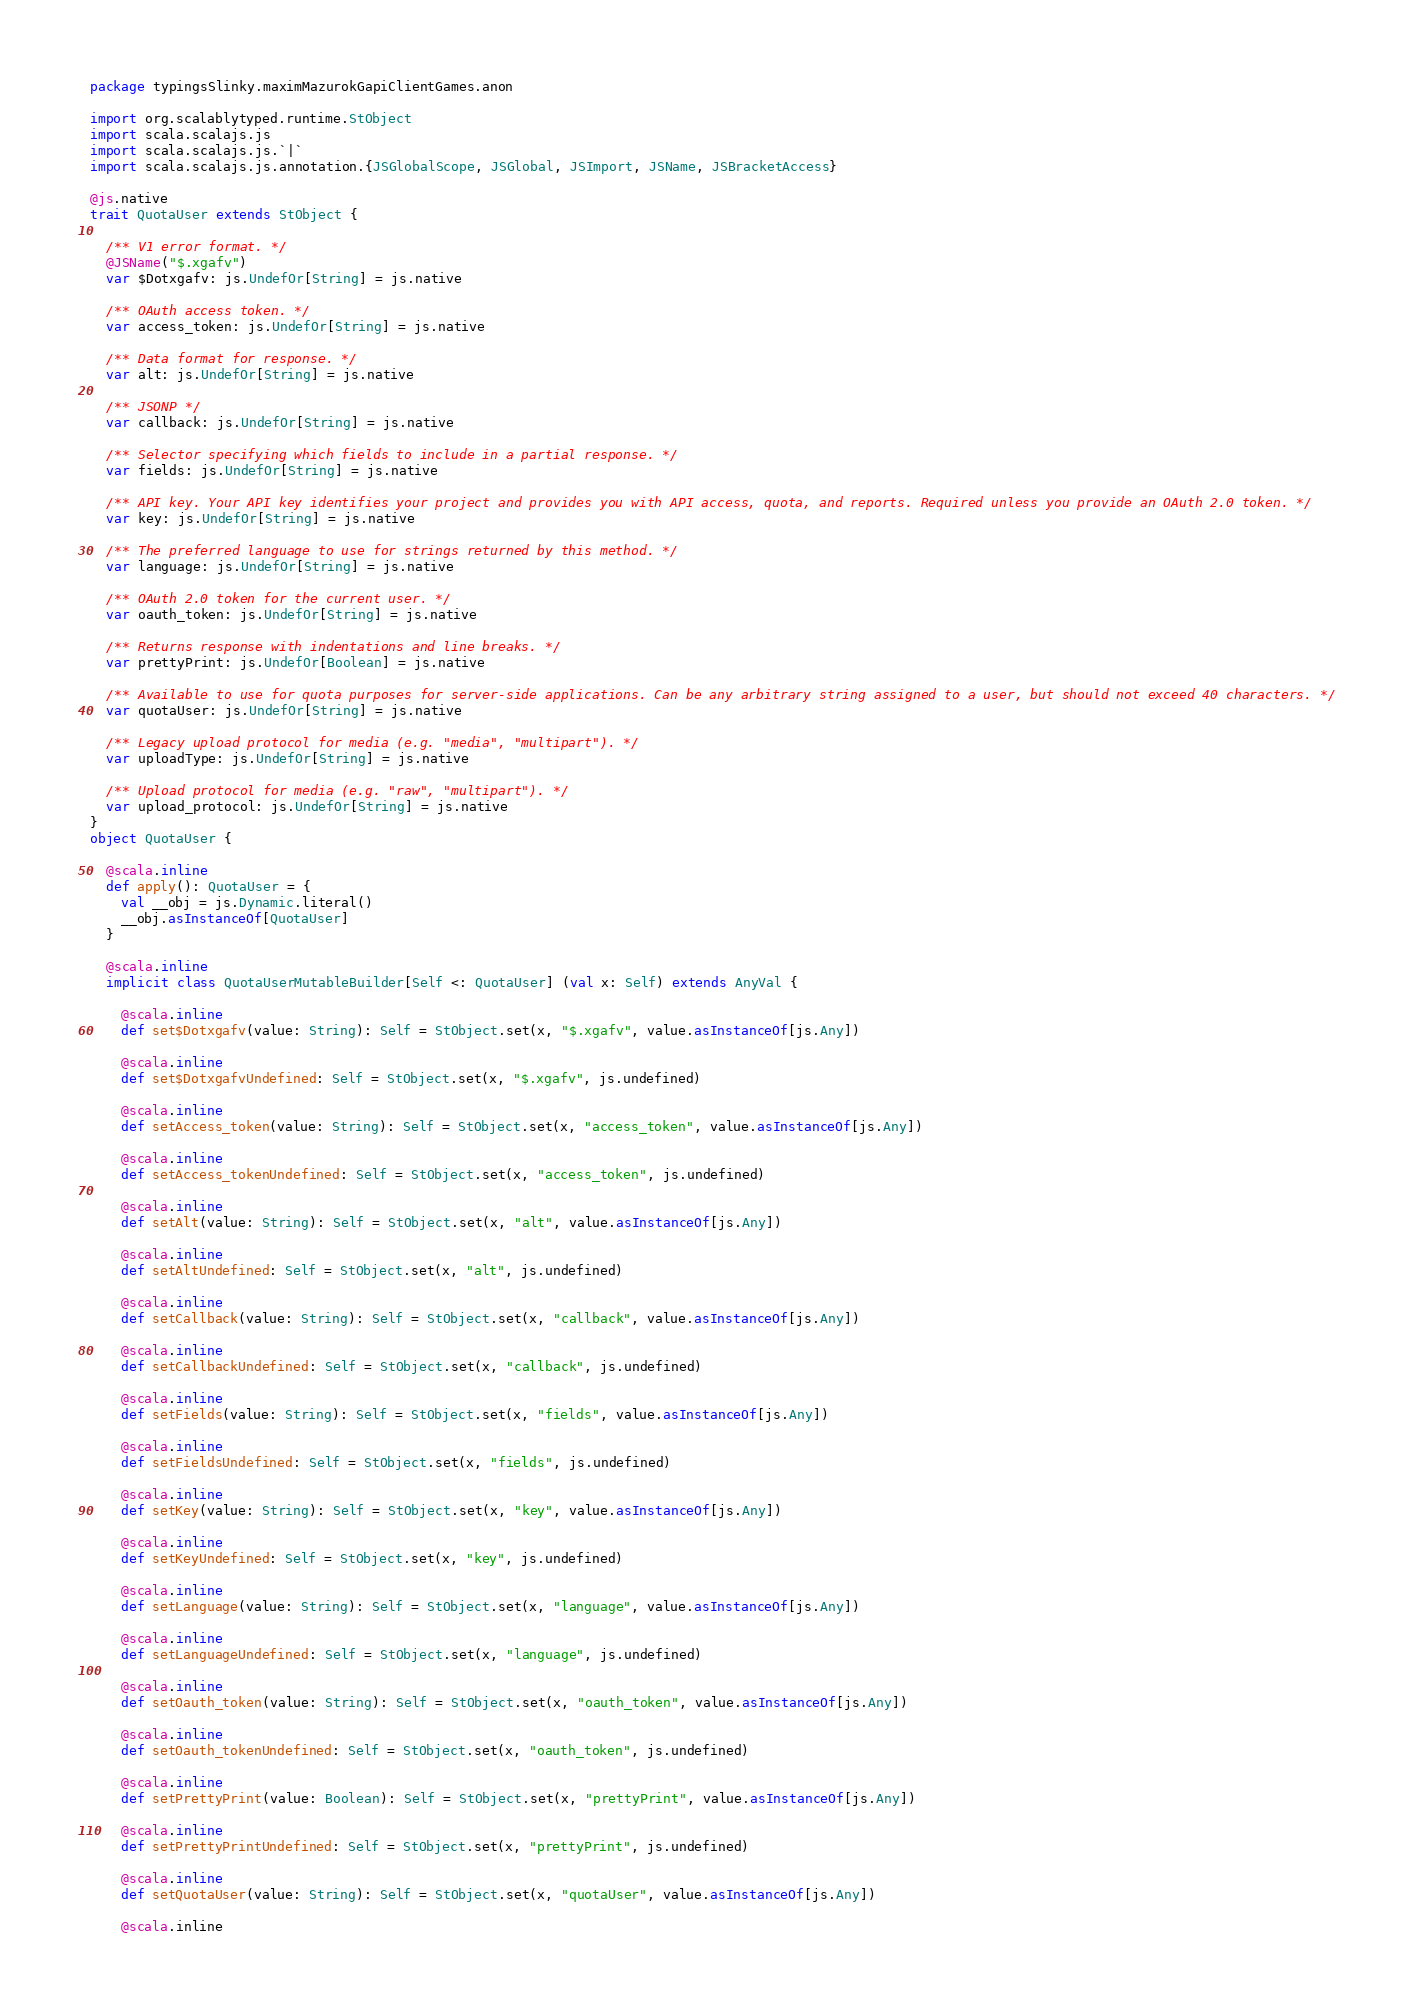Convert code to text. <code><loc_0><loc_0><loc_500><loc_500><_Scala_>package typingsSlinky.maximMazurokGapiClientGames.anon

import org.scalablytyped.runtime.StObject
import scala.scalajs.js
import scala.scalajs.js.`|`
import scala.scalajs.js.annotation.{JSGlobalScope, JSGlobal, JSImport, JSName, JSBracketAccess}

@js.native
trait QuotaUser extends StObject {
  
  /** V1 error format. */
  @JSName("$.xgafv")
  var $Dotxgafv: js.UndefOr[String] = js.native
  
  /** OAuth access token. */
  var access_token: js.UndefOr[String] = js.native
  
  /** Data format for response. */
  var alt: js.UndefOr[String] = js.native
  
  /** JSONP */
  var callback: js.UndefOr[String] = js.native
  
  /** Selector specifying which fields to include in a partial response. */
  var fields: js.UndefOr[String] = js.native
  
  /** API key. Your API key identifies your project and provides you with API access, quota, and reports. Required unless you provide an OAuth 2.0 token. */
  var key: js.UndefOr[String] = js.native
  
  /** The preferred language to use for strings returned by this method. */
  var language: js.UndefOr[String] = js.native
  
  /** OAuth 2.0 token for the current user. */
  var oauth_token: js.UndefOr[String] = js.native
  
  /** Returns response with indentations and line breaks. */
  var prettyPrint: js.UndefOr[Boolean] = js.native
  
  /** Available to use for quota purposes for server-side applications. Can be any arbitrary string assigned to a user, but should not exceed 40 characters. */
  var quotaUser: js.UndefOr[String] = js.native
  
  /** Legacy upload protocol for media (e.g. "media", "multipart"). */
  var uploadType: js.UndefOr[String] = js.native
  
  /** Upload protocol for media (e.g. "raw", "multipart"). */
  var upload_protocol: js.UndefOr[String] = js.native
}
object QuotaUser {
  
  @scala.inline
  def apply(): QuotaUser = {
    val __obj = js.Dynamic.literal()
    __obj.asInstanceOf[QuotaUser]
  }
  
  @scala.inline
  implicit class QuotaUserMutableBuilder[Self <: QuotaUser] (val x: Self) extends AnyVal {
    
    @scala.inline
    def set$Dotxgafv(value: String): Self = StObject.set(x, "$.xgafv", value.asInstanceOf[js.Any])
    
    @scala.inline
    def set$DotxgafvUndefined: Self = StObject.set(x, "$.xgafv", js.undefined)
    
    @scala.inline
    def setAccess_token(value: String): Self = StObject.set(x, "access_token", value.asInstanceOf[js.Any])
    
    @scala.inline
    def setAccess_tokenUndefined: Self = StObject.set(x, "access_token", js.undefined)
    
    @scala.inline
    def setAlt(value: String): Self = StObject.set(x, "alt", value.asInstanceOf[js.Any])
    
    @scala.inline
    def setAltUndefined: Self = StObject.set(x, "alt", js.undefined)
    
    @scala.inline
    def setCallback(value: String): Self = StObject.set(x, "callback", value.asInstanceOf[js.Any])
    
    @scala.inline
    def setCallbackUndefined: Self = StObject.set(x, "callback", js.undefined)
    
    @scala.inline
    def setFields(value: String): Self = StObject.set(x, "fields", value.asInstanceOf[js.Any])
    
    @scala.inline
    def setFieldsUndefined: Self = StObject.set(x, "fields", js.undefined)
    
    @scala.inline
    def setKey(value: String): Self = StObject.set(x, "key", value.asInstanceOf[js.Any])
    
    @scala.inline
    def setKeyUndefined: Self = StObject.set(x, "key", js.undefined)
    
    @scala.inline
    def setLanguage(value: String): Self = StObject.set(x, "language", value.asInstanceOf[js.Any])
    
    @scala.inline
    def setLanguageUndefined: Self = StObject.set(x, "language", js.undefined)
    
    @scala.inline
    def setOauth_token(value: String): Self = StObject.set(x, "oauth_token", value.asInstanceOf[js.Any])
    
    @scala.inline
    def setOauth_tokenUndefined: Self = StObject.set(x, "oauth_token", js.undefined)
    
    @scala.inline
    def setPrettyPrint(value: Boolean): Self = StObject.set(x, "prettyPrint", value.asInstanceOf[js.Any])
    
    @scala.inline
    def setPrettyPrintUndefined: Self = StObject.set(x, "prettyPrint", js.undefined)
    
    @scala.inline
    def setQuotaUser(value: String): Self = StObject.set(x, "quotaUser", value.asInstanceOf[js.Any])
    
    @scala.inline</code> 